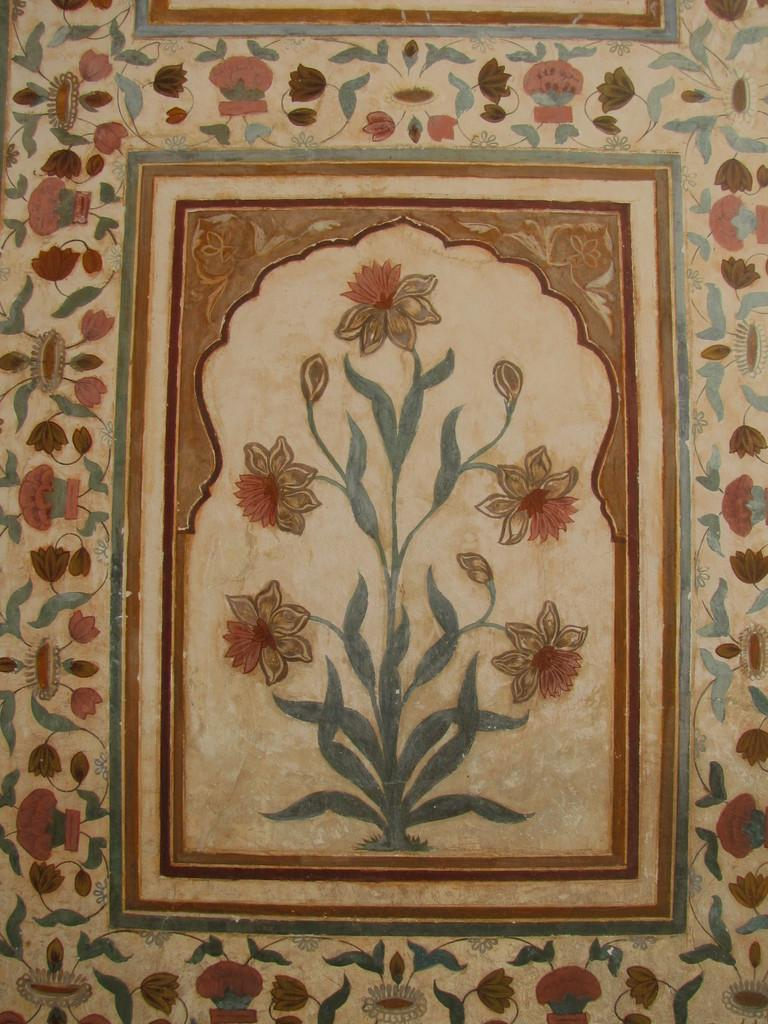What is depicted on the wall in the image? There is a wall painting in the image. What is the main subject of the wall painting? The wall painting contains a flower plant. What room does the flower plant have an effect on in the image? The image does not show a room, and the flower plant is a part of the wall painting, so it does not have an effect on a room in the image. 